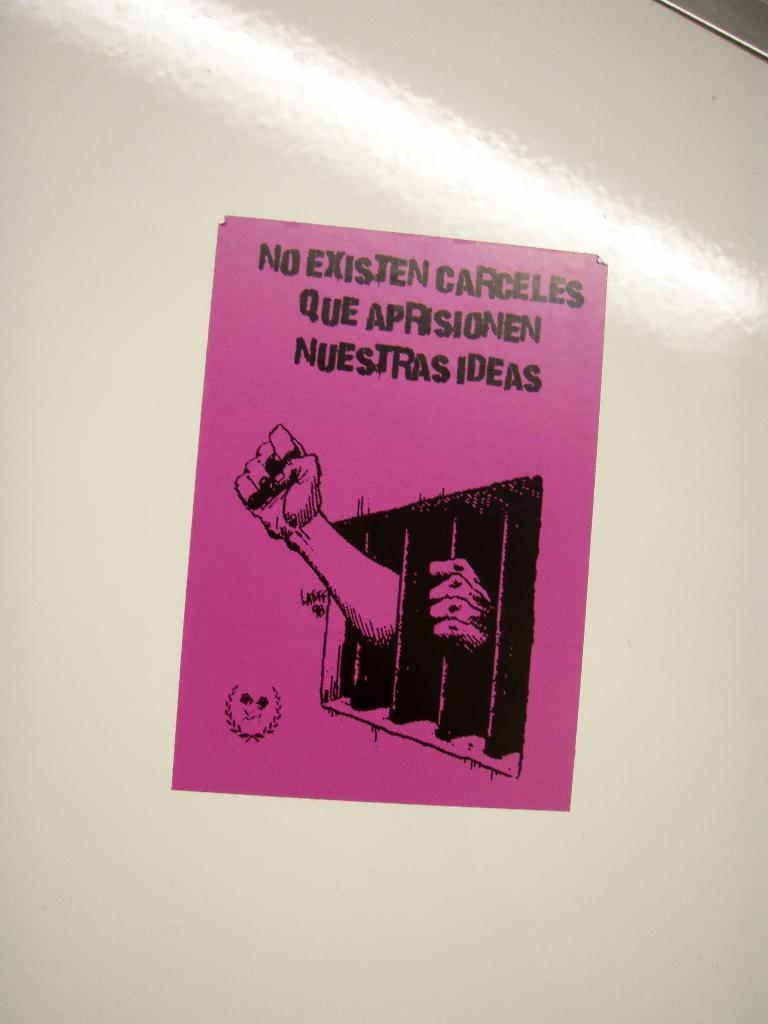<image>
Provide a brief description of the given image. a purple sign on a wall that says 'no existen carceles que aprisionen nuestras ideas' 